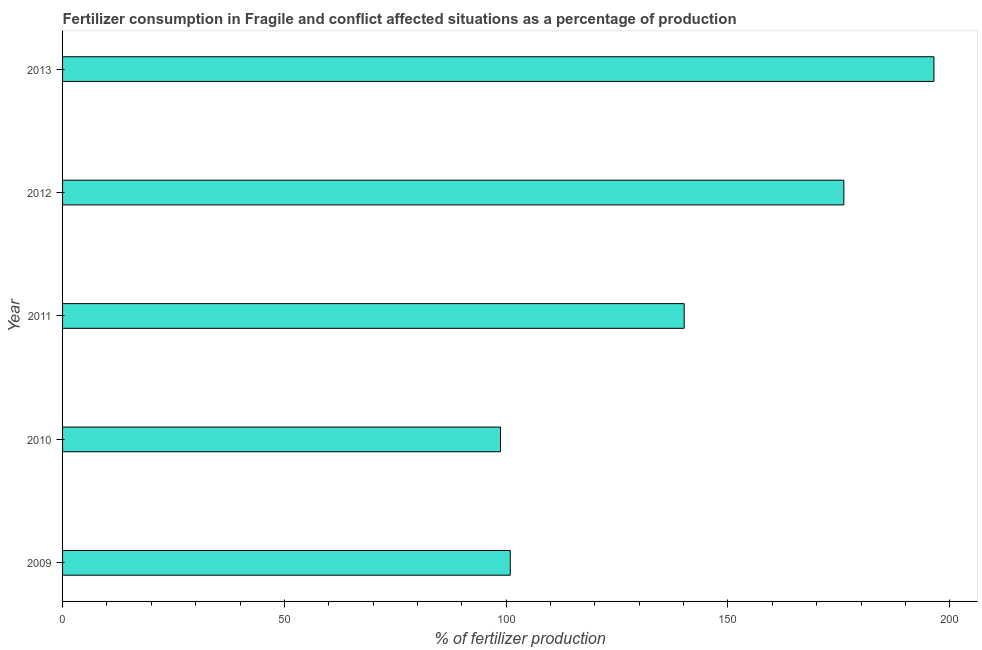Does the graph contain grids?
Make the answer very short. No. What is the title of the graph?
Make the answer very short. Fertilizer consumption in Fragile and conflict affected situations as a percentage of production. What is the label or title of the X-axis?
Make the answer very short. % of fertilizer production. What is the label or title of the Y-axis?
Your answer should be very brief. Year. What is the amount of fertilizer consumption in 2012?
Your answer should be very brief. 176.14. Across all years, what is the maximum amount of fertilizer consumption?
Give a very brief answer. 196.44. Across all years, what is the minimum amount of fertilizer consumption?
Give a very brief answer. 98.72. What is the sum of the amount of fertilizer consumption?
Your answer should be very brief. 712.35. What is the difference between the amount of fertilizer consumption in 2009 and 2010?
Your response must be concise. 2.21. What is the average amount of fertilizer consumption per year?
Your answer should be compact. 142.47. What is the median amount of fertilizer consumption?
Provide a succinct answer. 140.13. In how many years, is the amount of fertilizer consumption greater than 50 %?
Offer a very short reply. 5. What is the ratio of the amount of fertilizer consumption in 2010 to that in 2013?
Provide a short and direct response. 0.5. Is the amount of fertilizer consumption in 2012 less than that in 2013?
Your answer should be compact. Yes. Is the difference between the amount of fertilizer consumption in 2009 and 2013 greater than the difference between any two years?
Make the answer very short. No. What is the difference between the highest and the second highest amount of fertilizer consumption?
Provide a short and direct response. 20.3. Is the sum of the amount of fertilizer consumption in 2009 and 2012 greater than the maximum amount of fertilizer consumption across all years?
Give a very brief answer. Yes. What is the difference between the highest and the lowest amount of fertilizer consumption?
Make the answer very short. 97.72. In how many years, is the amount of fertilizer consumption greater than the average amount of fertilizer consumption taken over all years?
Ensure brevity in your answer.  2. How many years are there in the graph?
Ensure brevity in your answer.  5. What is the difference between two consecutive major ticks on the X-axis?
Offer a terse response. 50. Are the values on the major ticks of X-axis written in scientific E-notation?
Your response must be concise. No. What is the % of fertilizer production of 2009?
Provide a short and direct response. 100.93. What is the % of fertilizer production in 2010?
Offer a very short reply. 98.72. What is the % of fertilizer production in 2011?
Your response must be concise. 140.13. What is the % of fertilizer production of 2012?
Keep it short and to the point. 176.14. What is the % of fertilizer production of 2013?
Keep it short and to the point. 196.44. What is the difference between the % of fertilizer production in 2009 and 2010?
Make the answer very short. 2.21. What is the difference between the % of fertilizer production in 2009 and 2011?
Ensure brevity in your answer.  -39.2. What is the difference between the % of fertilizer production in 2009 and 2012?
Provide a short and direct response. -75.21. What is the difference between the % of fertilizer production in 2009 and 2013?
Provide a short and direct response. -95.51. What is the difference between the % of fertilizer production in 2010 and 2011?
Provide a short and direct response. -41.41. What is the difference between the % of fertilizer production in 2010 and 2012?
Make the answer very short. -77.42. What is the difference between the % of fertilizer production in 2010 and 2013?
Provide a short and direct response. -97.72. What is the difference between the % of fertilizer production in 2011 and 2012?
Provide a succinct answer. -36.01. What is the difference between the % of fertilizer production in 2011 and 2013?
Your answer should be very brief. -56.31. What is the difference between the % of fertilizer production in 2012 and 2013?
Offer a very short reply. -20.3. What is the ratio of the % of fertilizer production in 2009 to that in 2011?
Give a very brief answer. 0.72. What is the ratio of the % of fertilizer production in 2009 to that in 2012?
Your response must be concise. 0.57. What is the ratio of the % of fertilizer production in 2009 to that in 2013?
Provide a succinct answer. 0.51. What is the ratio of the % of fertilizer production in 2010 to that in 2011?
Make the answer very short. 0.7. What is the ratio of the % of fertilizer production in 2010 to that in 2012?
Ensure brevity in your answer.  0.56. What is the ratio of the % of fertilizer production in 2010 to that in 2013?
Make the answer very short. 0.5. What is the ratio of the % of fertilizer production in 2011 to that in 2012?
Your response must be concise. 0.8. What is the ratio of the % of fertilizer production in 2011 to that in 2013?
Keep it short and to the point. 0.71. What is the ratio of the % of fertilizer production in 2012 to that in 2013?
Provide a short and direct response. 0.9. 